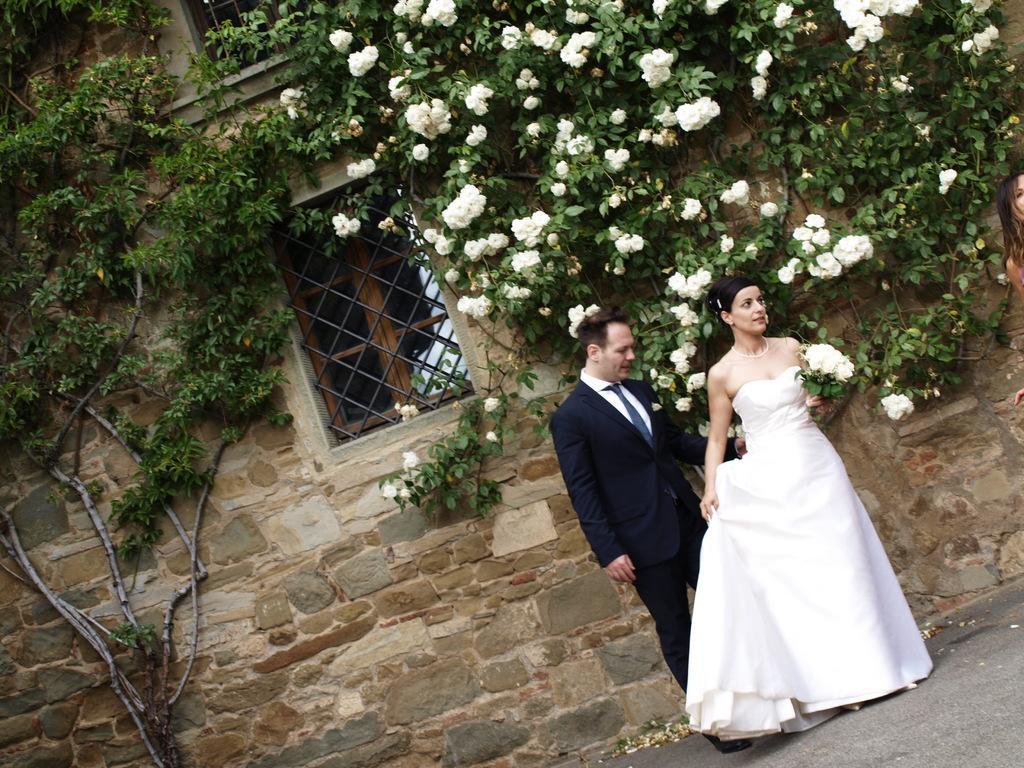Could you give a brief overview of what you see in this image? In this image there is a man and a woman standing on the surface, the woman is holding a bouquet of flowers in her hand, behind them there is a building with flowers and leaves hanging on the wall. 